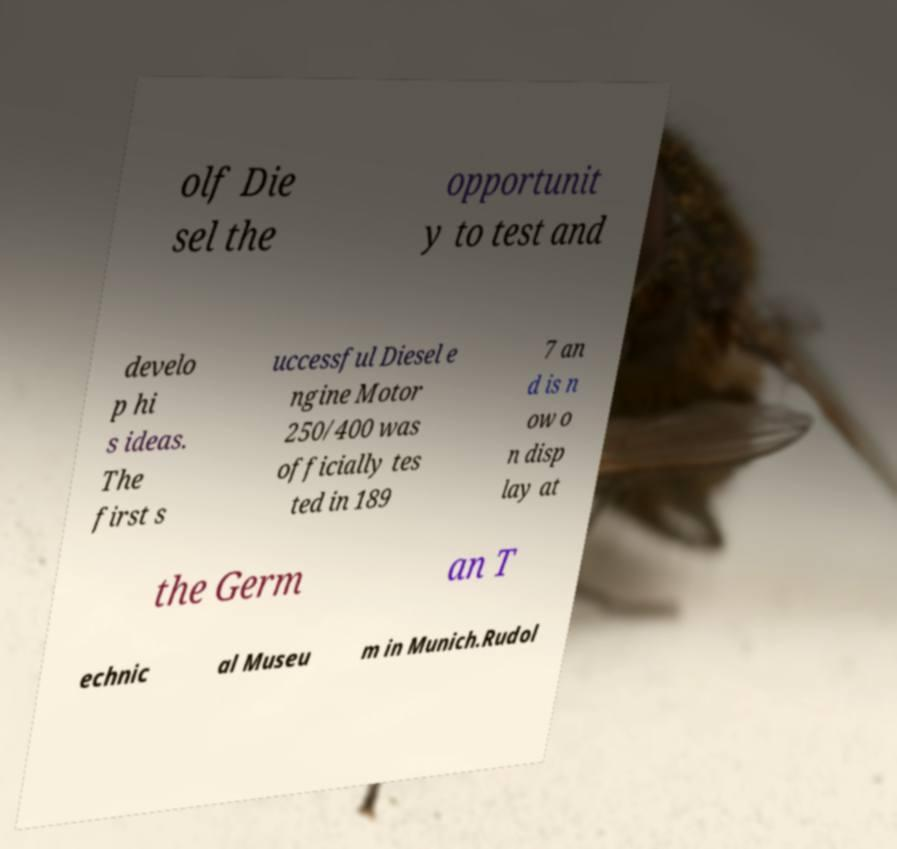For documentation purposes, I need the text within this image transcribed. Could you provide that? olf Die sel the opportunit y to test and develo p hi s ideas. The first s uccessful Diesel e ngine Motor 250/400 was officially tes ted in 189 7 an d is n ow o n disp lay at the Germ an T echnic al Museu m in Munich.Rudol 